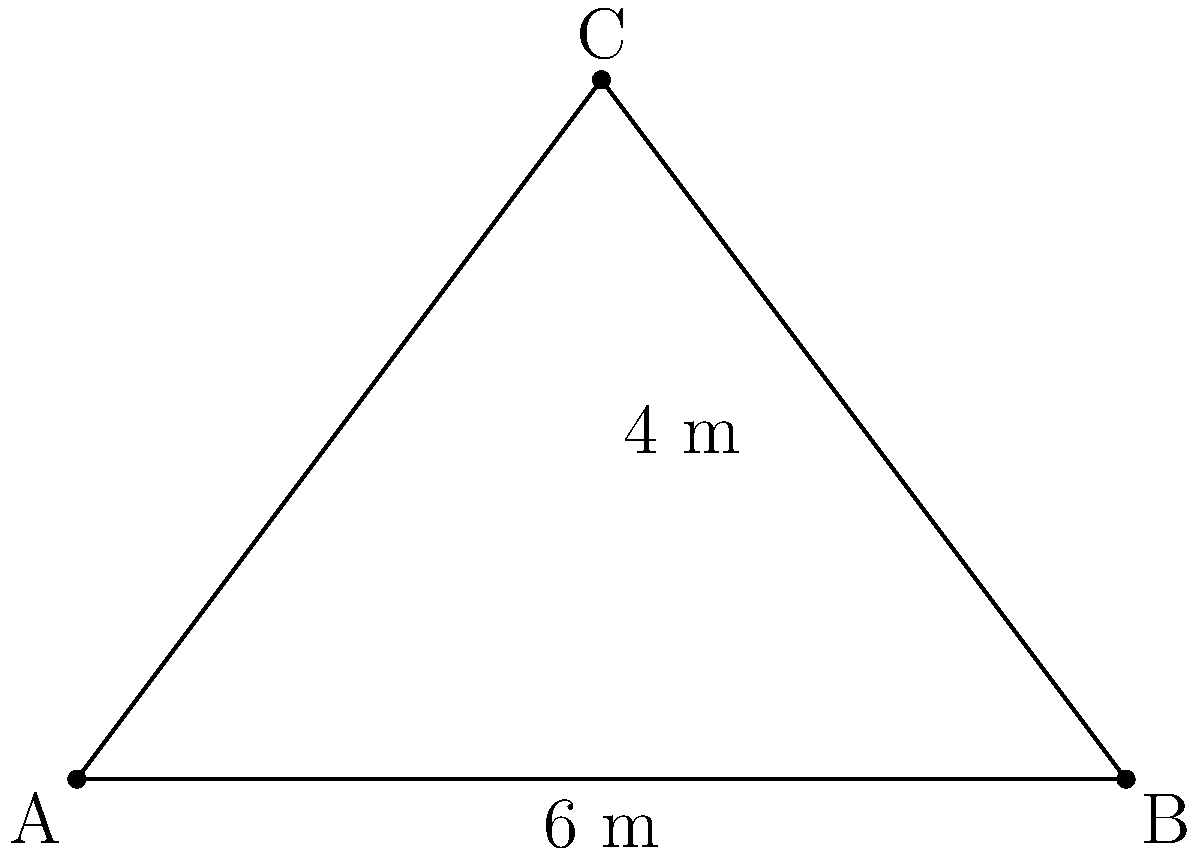In an urban renewal project, you're designing a campaign for a triangular green space. The space is wedged between city structures, forming a right-angled triangle. If the base of the triangle is 6 meters and the height is 4 meters, what is the area of this green space? To find the area of a triangular green space, we can use the formula for the area of a triangle:

$$ \text{Area} = \frac{1}{2} \times \text{base} \times \text{height} $$

Given:
- Base of the triangle = 6 meters
- Height of the triangle = 4 meters

Let's substitute these values into the formula:

$$ \text{Area} = \frac{1}{2} \times 6 \text{ m} \times 4 \text{ m} $$

$$ \text{Area} = \frac{1}{2} \times 24 \text{ m}^2 $$

$$ \text{Area} = 12 \text{ m}^2 $$

Therefore, the area of the triangular green space is 12 square meters.
Answer: 12 m² 